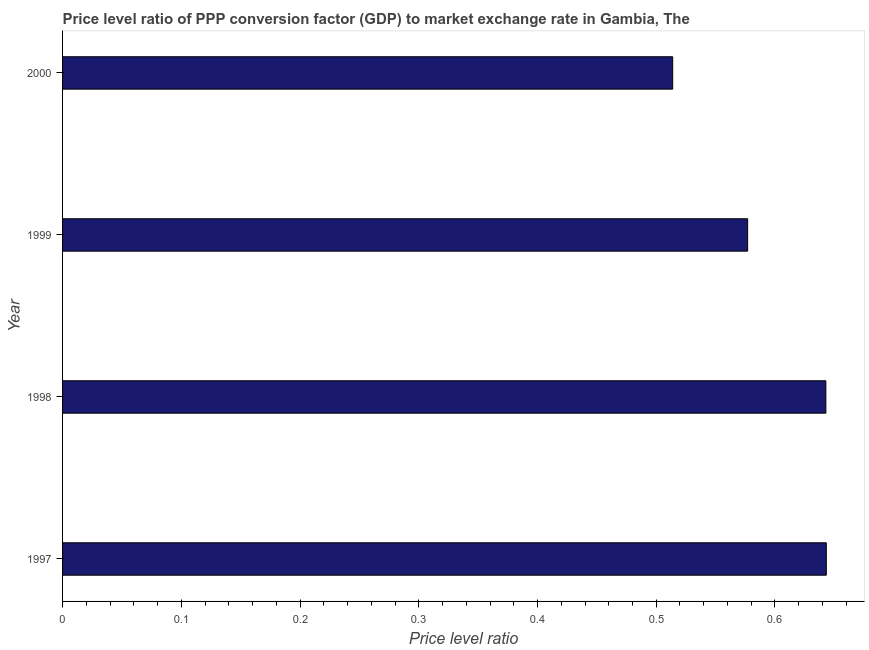What is the title of the graph?
Your answer should be compact. Price level ratio of PPP conversion factor (GDP) to market exchange rate in Gambia, The. What is the label or title of the X-axis?
Offer a terse response. Price level ratio. What is the price level ratio in 1998?
Ensure brevity in your answer.  0.64. Across all years, what is the maximum price level ratio?
Your answer should be very brief. 0.64. Across all years, what is the minimum price level ratio?
Your response must be concise. 0.51. In which year was the price level ratio minimum?
Provide a short and direct response. 2000. What is the sum of the price level ratio?
Keep it short and to the point. 2.38. What is the difference between the price level ratio in 1997 and 2000?
Provide a short and direct response. 0.13. What is the average price level ratio per year?
Your answer should be compact. 0.59. What is the median price level ratio?
Provide a succinct answer. 0.61. Do a majority of the years between 1998 and 2000 (inclusive) have price level ratio greater than 0.06 ?
Give a very brief answer. Yes. What is the ratio of the price level ratio in 1997 to that in 1998?
Your answer should be very brief. 1. Is the price level ratio in 1997 less than that in 1999?
Provide a succinct answer. No. Is the difference between the price level ratio in 1997 and 1998 greater than the difference between any two years?
Give a very brief answer. No. What is the difference between the highest and the second highest price level ratio?
Provide a succinct answer. 0. Is the sum of the price level ratio in 1997 and 1999 greater than the maximum price level ratio across all years?
Your answer should be compact. Yes. What is the difference between the highest and the lowest price level ratio?
Your answer should be very brief. 0.13. How many bars are there?
Make the answer very short. 4. Are the values on the major ticks of X-axis written in scientific E-notation?
Give a very brief answer. No. What is the Price level ratio of 1997?
Provide a short and direct response. 0.64. What is the Price level ratio of 1998?
Ensure brevity in your answer.  0.64. What is the Price level ratio in 1999?
Provide a short and direct response. 0.58. What is the Price level ratio in 2000?
Your response must be concise. 0.51. What is the difference between the Price level ratio in 1997 and 1998?
Offer a terse response. 0. What is the difference between the Price level ratio in 1997 and 1999?
Your answer should be very brief. 0.07. What is the difference between the Price level ratio in 1997 and 2000?
Give a very brief answer. 0.13. What is the difference between the Price level ratio in 1998 and 1999?
Provide a short and direct response. 0.07. What is the difference between the Price level ratio in 1998 and 2000?
Give a very brief answer. 0.13. What is the difference between the Price level ratio in 1999 and 2000?
Your response must be concise. 0.06. What is the ratio of the Price level ratio in 1997 to that in 1998?
Your response must be concise. 1. What is the ratio of the Price level ratio in 1997 to that in 1999?
Give a very brief answer. 1.11. What is the ratio of the Price level ratio in 1997 to that in 2000?
Offer a terse response. 1.25. What is the ratio of the Price level ratio in 1998 to that in 1999?
Ensure brevity in your answer.  1.11. What is the ratio of the Price level ratio in 1998 to that in 2000?
Offer a terse response. 1.25. What is the ratio of the Price level ratio in 1999 to that in 2000?
Ensure brevity in your answer.  1.12. 